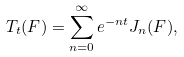Convert formula to latex. <formula><loc_0><loc_0><loc_500><loc_500>T _ { t } ( F ) = \sum _ { n = 0 } ^ { \infty } e ^ { - n t } J _ { n } ( F ) ,</formula> 